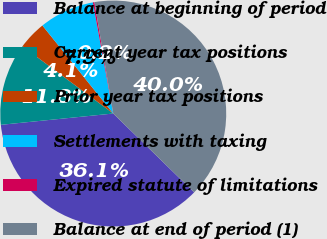Convert chart. <chart><loc_0><loc_0><loc_500><loc_500><pie_chart><fcel>Balance at beginning of period<fcel>Current year tax positions<fcel>Prior year tax positions<fcel>Settlements with taxing<fcel>Expired statute of limitations<fcel>Balance at end of period (1)<nl><fcel>36.11%<fcel>11.75%<fcel>4.06%<fcel>7.9%<fcel>0.22%<fcel>39.96%<nl></chart> 